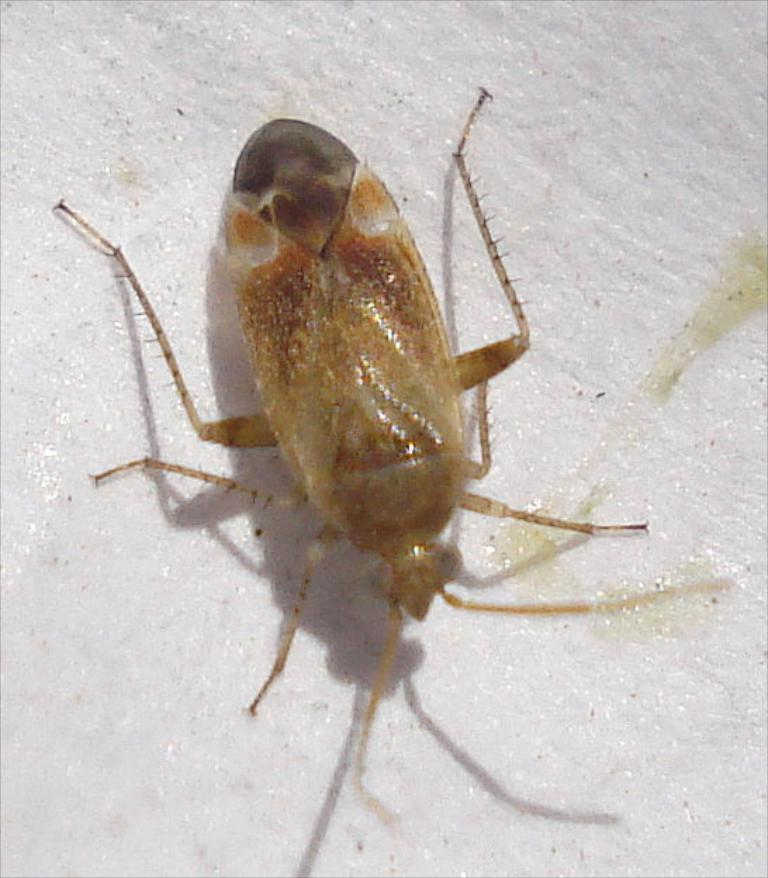What type of creature can be seen in the image? There is an insect in the image. Where is the insect located? The insect is on a white platform. How many pigs are present in the image? There are no pigs present in the image; it features an insect on a white platform. What type of metal can be seen in the image? There is no metal present in the image. 